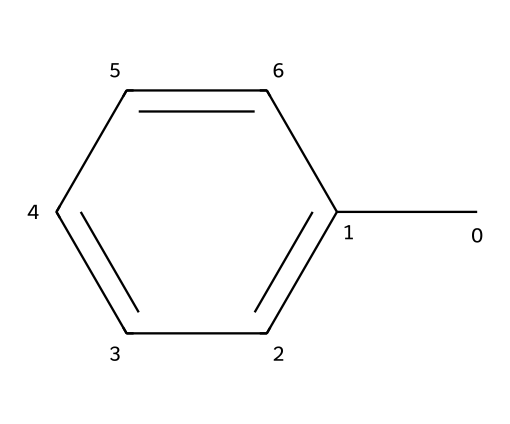What is the number of carbon atoms in toluene? By examining the SMILES representation, we see "Cc1ccccc1". The "C" at the beginning represents a carbon atom (methyl group), and the "c" characters represent the carbon atoms in the aromatic benzene ring. There are a total of seven "C" or "c" characters in this structure, indicating seven carbon atoms.
Answer: seven What functional group is present in toluene? The structure shows the presence of a methyl group (the "C" at the start) attached to a benzene ring (the "ccccc" part). The combination indicates that the functional group present is an alkyl group, specifically a methyl group attached to an aromatic ring.
Answer: methyl How many hydrogen atoms are in toluene? From the structure, we deduce the number of hydrogen atoms. There are three hydrogen atoms directly connected to the methyl group and five hydrogen atoms connected to the benzene ring. Adding these gives a total of eight hydrogen atoms.
Answer: eight Is toluene polar or non-polar? The structure of toluene shows a symmetrical arrangement with only carbon and hydrogen atoms, and the relatively even distribution of charge indicates that it is non-polar. Hence, toluene is classified as a non-polar solvent.
Answer: non-polar What type of solvent is toluene primarily classified as? Given its chemical structure and properties, toluene is primarily used as an organic solvent. Its ability to dissolve many organic compounds places it in the category of non-polar organic solvents used in various applications, including screen printing.
Answer: organic solvent What is the relationship between toluene and benzene? Toluene is essentially benzene with one hydrogen atom replaced by a methyl group. This structural modification means that toluene retains most of the chemical properties of benzene while also introducing additional characteristics due to the methyl group.
Answer: derivative 